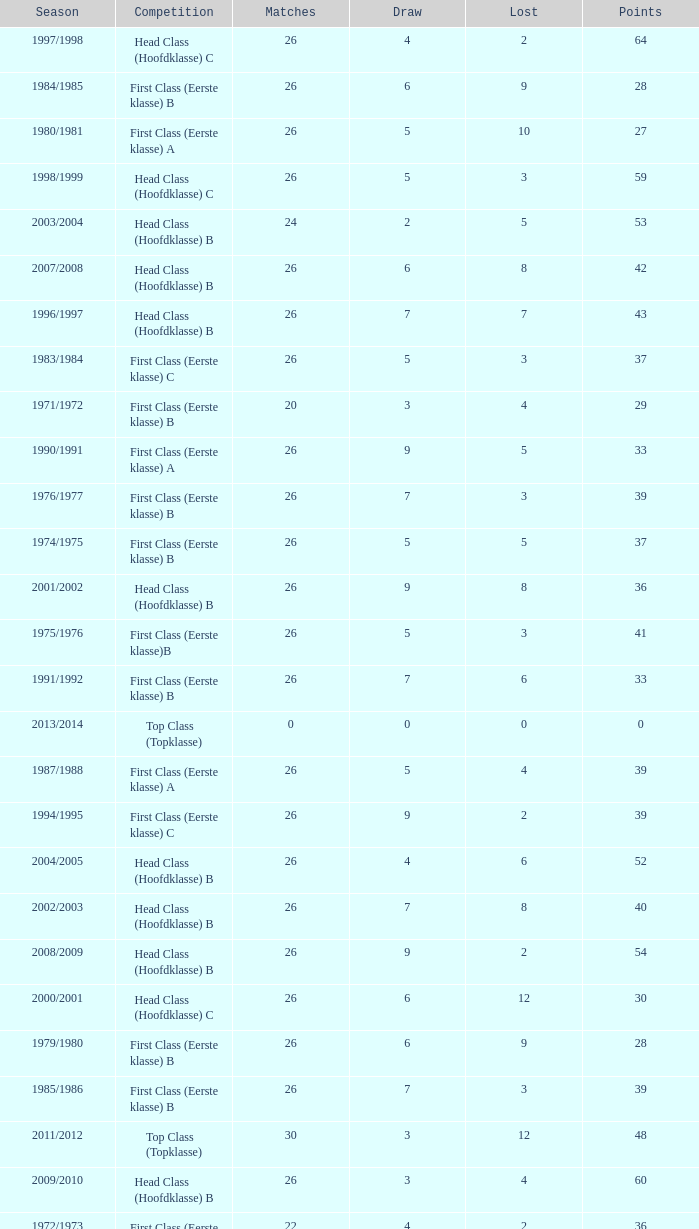What competition has a score greater than 30, a draw less than 5, and a loss larger than 10? Top Class (Topklasse). 